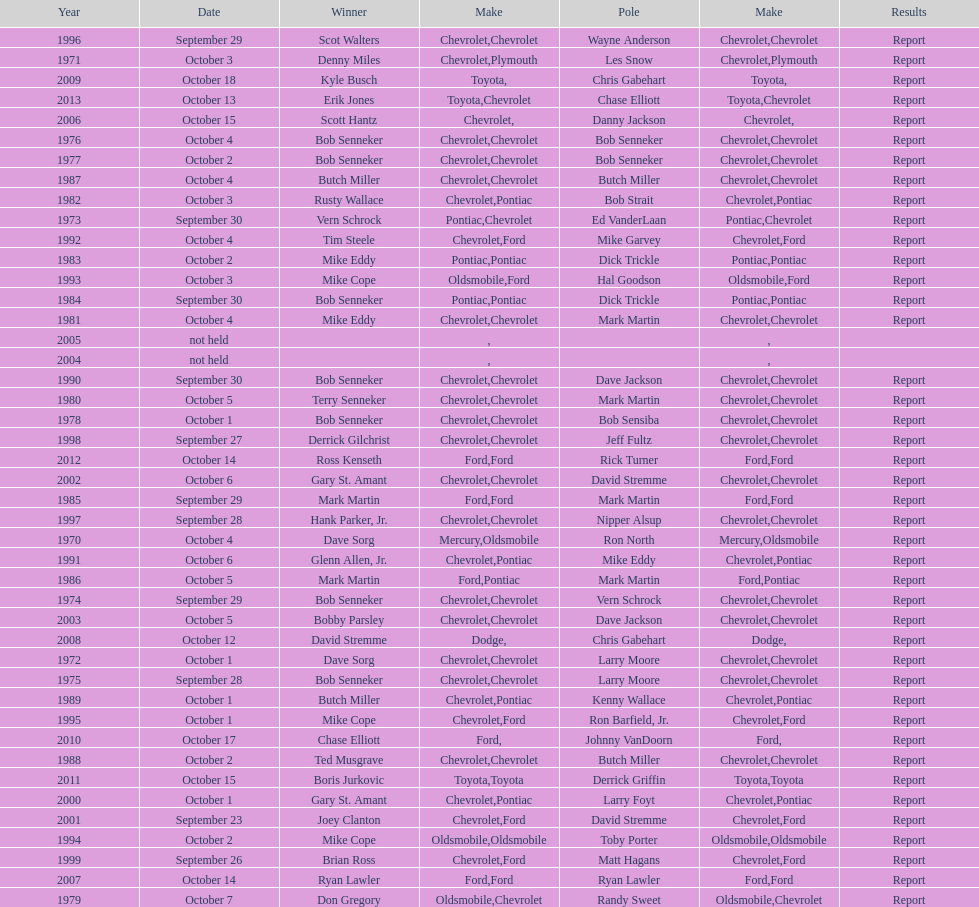Which make was used the least? Mercury. 